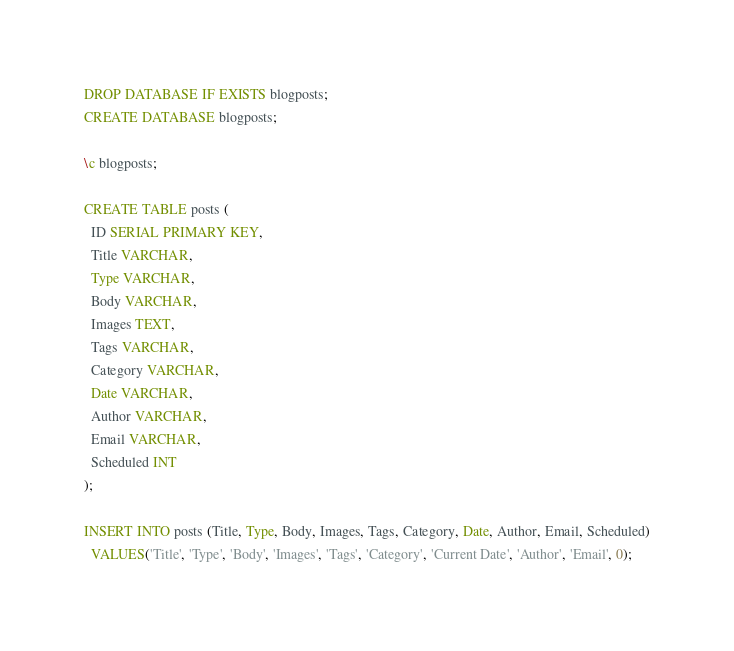Convert code to text. <code><loc_0><loc_0><loc_500><loc_500><_SQL_>DROP DATABASE IF EXISTS blogposts;
CREATE DATABASE blogposts;

\c blogposts;

CREATE TABLE posts (
  ID SERIAL PRIMARY KEY,
  Title VARCHAR,
  Type VARCHAR,
  Body VARCHAR,
  Images TEXT,
  Tags VARCHAR,
  Category VARCHAR,
  Date VARCHAR,
  Author VARCHAR,
  Email VARCHAR,
  Scheduled INT
);

INSERT INTO posts (Title, Type, Body, Images, Tags, Category, Date, Author, Email, Scheduled)
  VALUES('Title', 'Type', 'Body', 'Images', 'Tags', 'Category', 'Current Date', 'Author', 'Email', 0);
</code> 